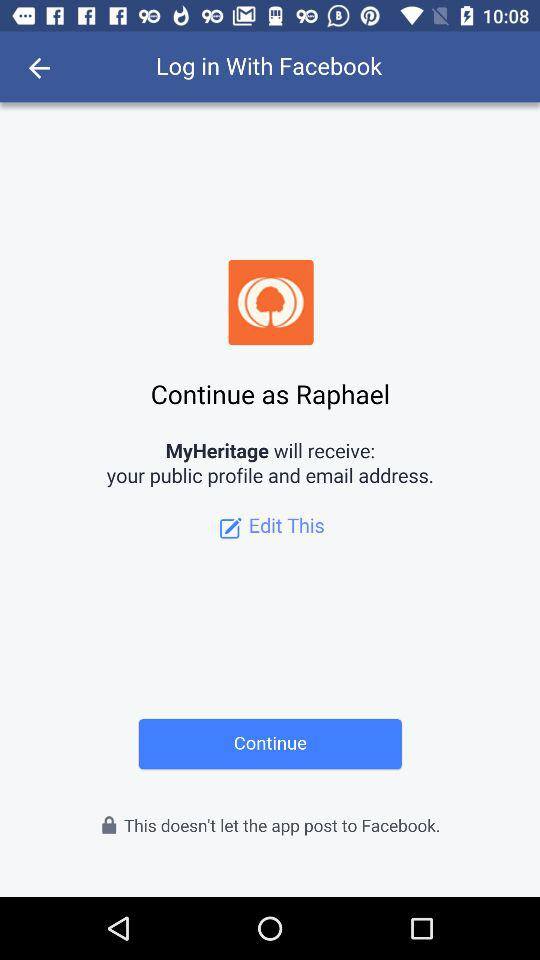What is the user name? The user name is Raphael. 